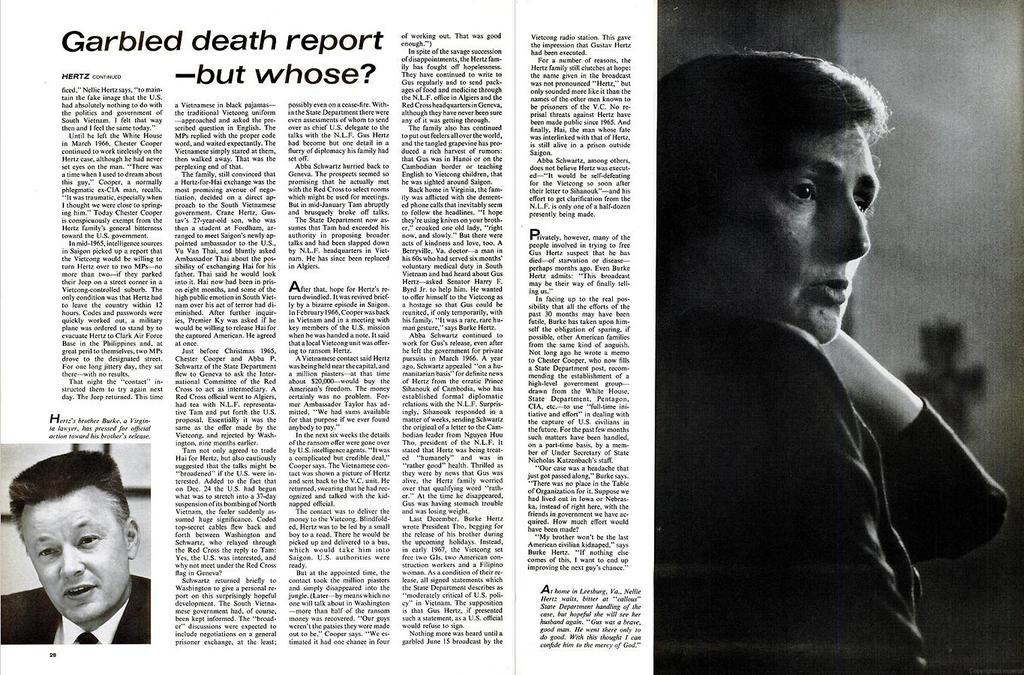What is present on the paper in the image? The paper contains text and two pictures. What can be found within the text on the paper? The text on the paper is not specified, but it is present. How many people are depicted in the images on the paper? There are two pictures on the paper, each depicting a different person. What type of bottle is shown in the image? There is no bottle present in the image; it only contains a paper with text and pictures. What is the condition of the tax in the image? There is no mention of tax in the image, as it only contains a paper with text and pictures. 